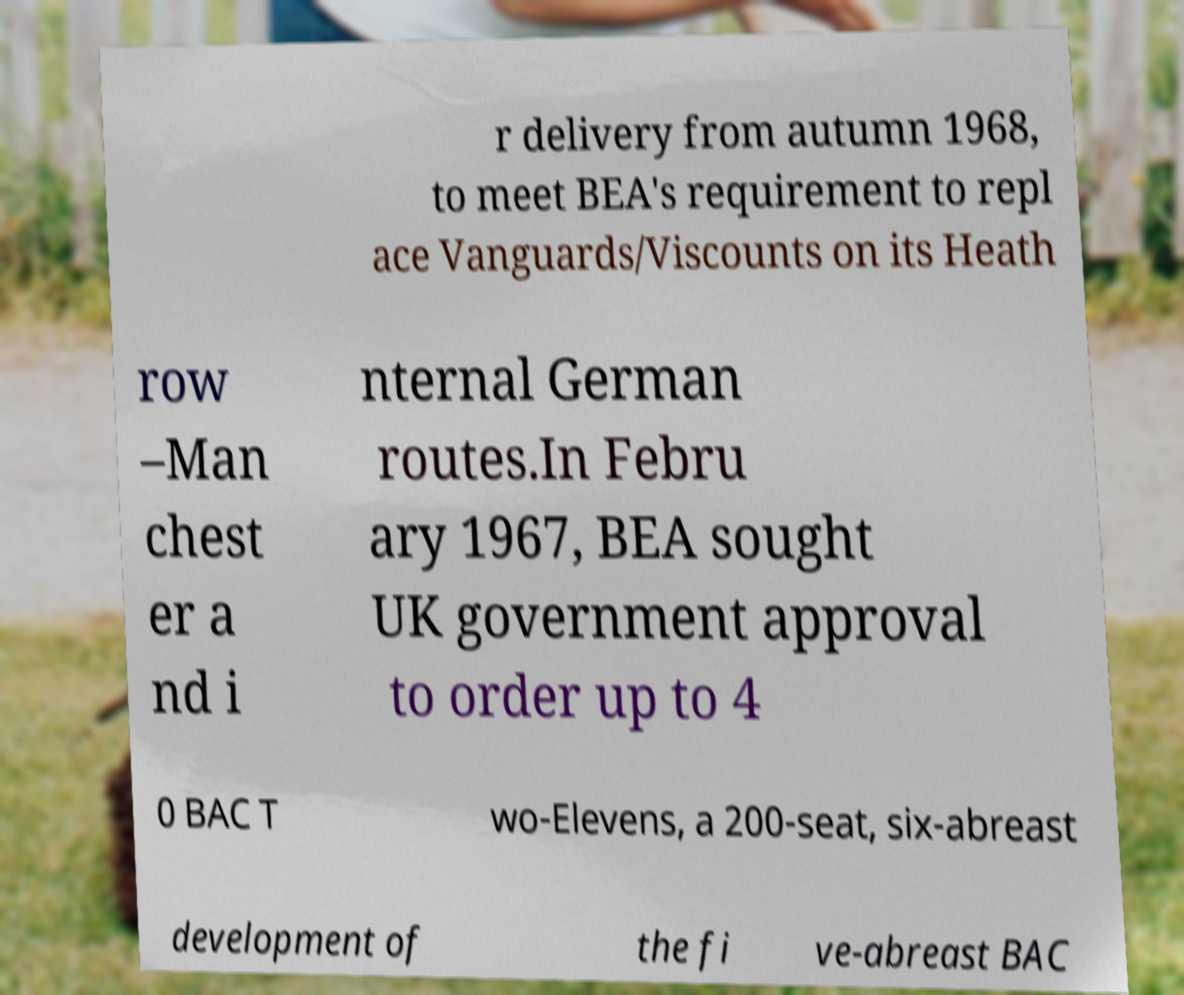Could you assist in decoding the text presented in this image and type it out clearly? r delivery from autumn 1968, to meet BEA's requirement to repl ace Vanguards/Viscounts on its Heath row –Man chest er a nd i nternal German routes.In Febru ary 1967, BEA sought UK government approval to order up to 4 0 BAC T wo-Elevens, a 200-seat, six-abreast development of the fi ve-abreast BAC 